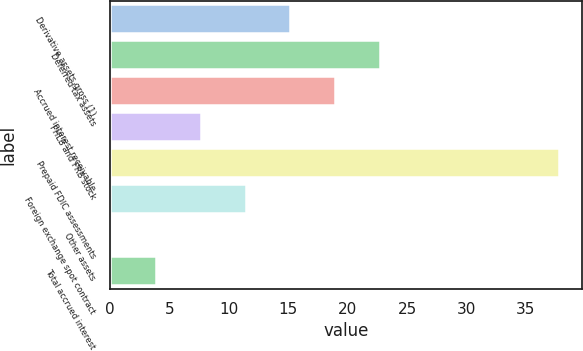Convert chart to OTSL. <chart><loc_0><loc_0><loc_500><loc_500><bar_chart><fcel>Derivative assets gross (1)<fcel>Deferred tax assets<fcel>Accrued interest receivable<fcel>FHLB and FRB stock<fcel>Prepaid FDIC assessments<fcel>Foreign exchange spot contract<fcel>Other assets<fcel>Total accrued interest<nl><fcel>15.18<fcel>22.72<fcel>18.95<fcel>7.64<fcel>37.8<fcel>11.41<fcel>0.1<fcel>3.87<nl></chart> 